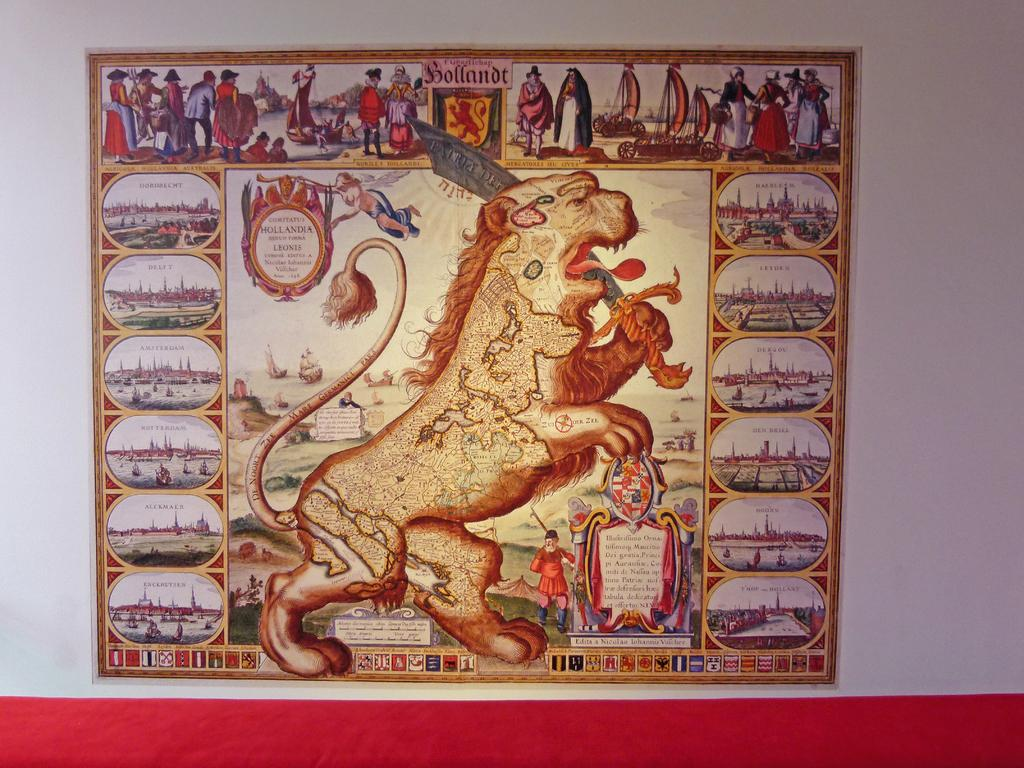What is present in the image that contains various images and text? There is a poster in the image that contains different images and text. Can you describe the images on the poster? Unfortunately, the specific images on the poster cannot be described without more information. What type of information is conveyed through the text on the poster? The content of the text on the poster cannot be determined without more information. How many babies are playing with a rabbit in the image? There are no babies or rabbits present in the image; it only features a poster with different images and text. 